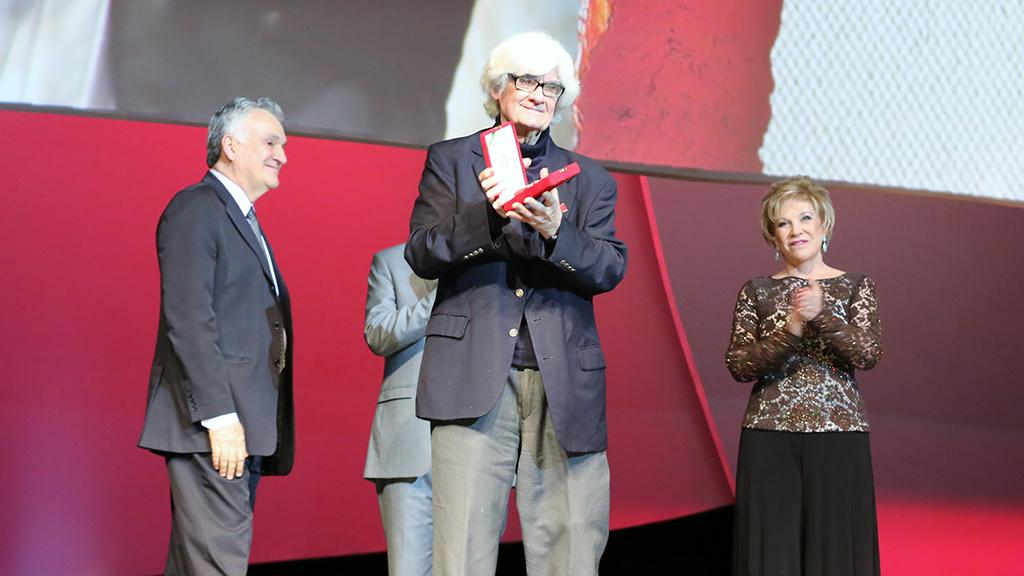How many people are present in the image? There are four people in the image. What are the people doing in the image? One of the people is holding an object. Can you describe the background setting in the image? Unfortunately, the provided facts do not give any information about the background setting. What type of fang can be seen on the person holding the object in the image? There is no mention of a fang or any animal-related objects in the image. 